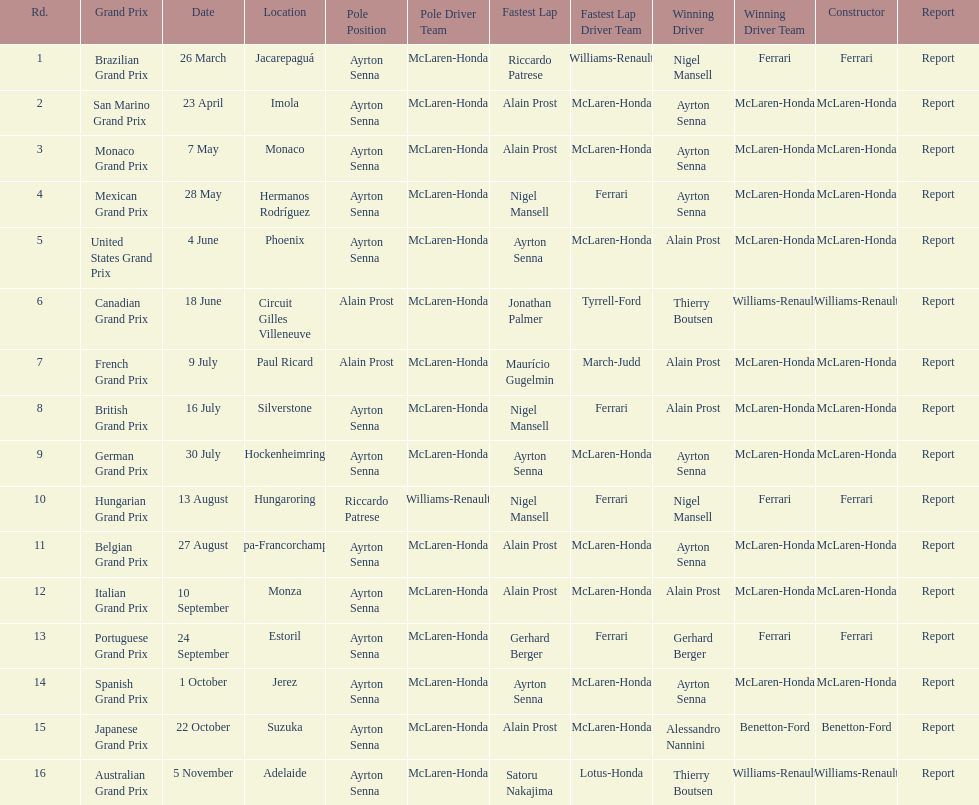Prost won the drivers title, who was his teammate? Ayrton Senna. 